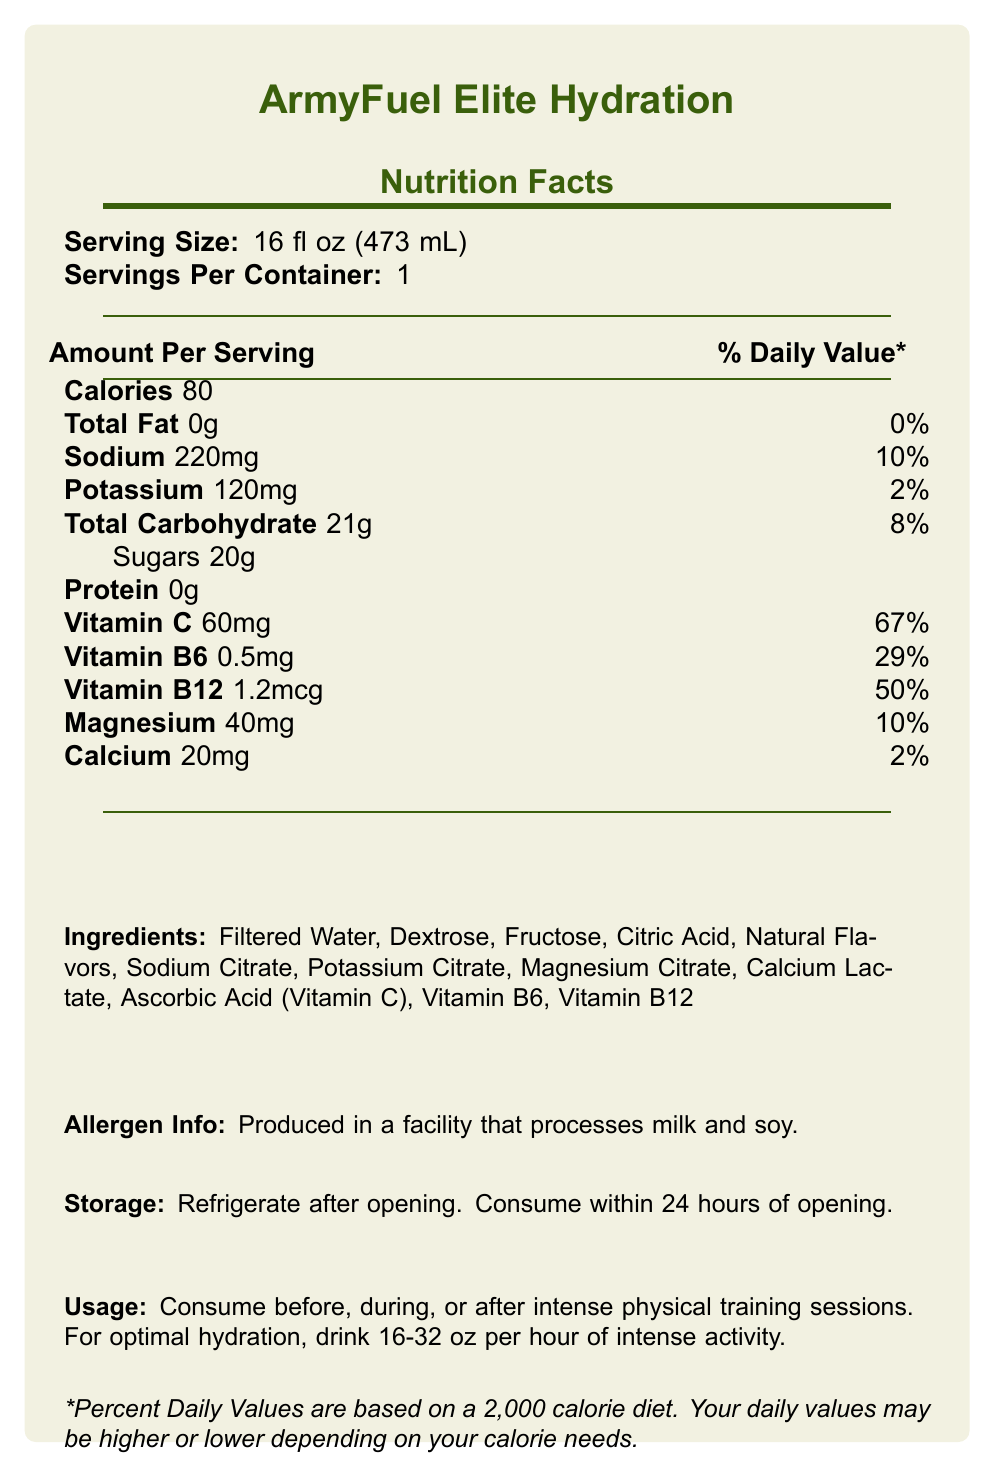what is the serving size of ArmyFuel Elite Hydration? The serving size is stated at the top of the nutrition facts section of the document.
Answer: 16 fl oz (473 mL) how many calories are in one serving? The calories per serving are listed under the "Amount Per Serving" section.
Answer: 80 what percentage of the daily value of Vitamin C does one serving of the drink provide? The percentage of the daily value for Vitamin C is listed (60mg, 67%).
Answer: 67% what are the key benefits of consuming ArmyFuel Elite Hydration? The key benefits are listed in the product description section.
Answer: Replenishes essential electrolytes, supports muscle function and reduces cramping, enhances endurance and stamina, promotes faster recovery what is the amount of potassium in one serving? The amount of potassium is provided in the nutrition facts section under "Amount Per Serving."
Answer: 120mg which ingredient is not listed: A. Fructose B. Sodium Citrate C. Ascorbic Acid D. Sucrose Sucrose is not listed among the ingredients; the other listed ingredients are present.
Answer: D. Sucrose what is the recommended storage instruction for ArmyFuel Elite Hydration? A. Store at room temperature B. Keep in a cool, dry place C. Refrigerate after opening D. Freeze before use The storage instructions are listed towards the bottom of the document: "Refrigerate after opening. Consume within 24 hours of opening."
Answer: C. Refrigerate after opening how should ArmyFuel Elite Hydration be consumed for optimal hydration during intense activity? A. Drink 8-16 oz per session B. Drink 16-32 oz per hour C. Drink 8-10 oz every hour D. Sip small amounts throughout the session The usage instructions recommend drinking 16-32 oz per hour of intense activity.
Answer: B. Drink 16-32 oz per hour does the label mention if the product contains any protein? The nutrition facts section under "Amount Per Serving" lists protein content as 0g.
Answer: No does the product contain any allergens? The allergen information states: "Produced in a facility that processes milk and soy."
Answer: Yes describe the main idea of the document The document covers the nutritional facts, key benefits, and usage/storage instructions for the electrolyte-enhanced sports drink, targeted at maintaining soldiers' performance during intense training.
Answer: ArmyFuel Elite Hydration is a specially formulated sports drink designed for Army Reserve soldiers to maintain peak performance during intense physical training, providing essential electrolytes and vitamins while promoting hydration and recovery. It includes comprehensive nutritional information, recommended usage instructions, key benefits, and storage guidelines. how many servings per container are there? It mentions that there is one serving per container in the nutrition facts section.
Answer: 1 what type of facility is the product produced in? Allergen information indicates the type of facility.
Answer: A facility that processes milk and soy what is the primary function of the drink as described in the product description? The product description highlights the drink's purpose and benefits.
Answer: To help maintain peak performance during intense physical training and promote rapid rehydration what is the percentage daily value of Vitamin B12 in the drink? The daily value percentage for Vitamin B12 is listed as 50% in the nutrition facts.
Answer: 50% how much magnesium is in one serving? The nutrition facts section lists the magnesium content.
Answer: 40mg who is the target audience for this product? The product description explicitly states it is formulated for Army Reserve soldiers undergoing intense physical training.
Answer: Army Reserve soldiers is there any vitamin B6 in the drink? The document lists vitamin B6 at 0.5mg per serving, which is 29% of the daily value.
Answer: Yes can the exact cost of the drink be found in the document? The nutritional facts label does not include any pricing information.
Answer: Cannot be determined 